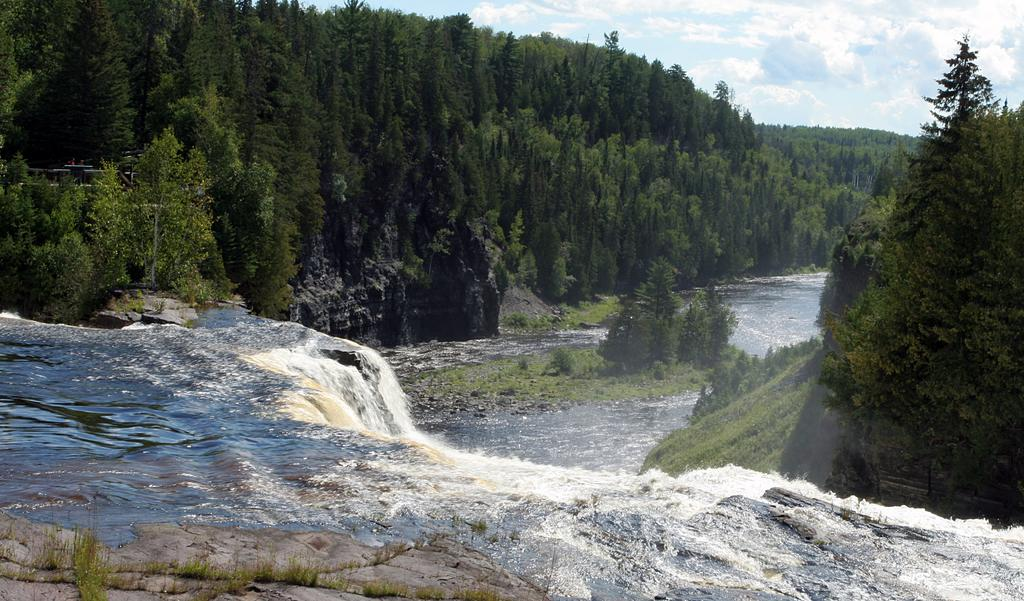What natural feature is the main subject of the image? There is a waterfall in the image. What can be seen in the background of the image? There are rocks and trees in the background of the image. What type of chin can be seen on the girl in the image? There is no girl present in the image; it features a waterfall and background elements. 